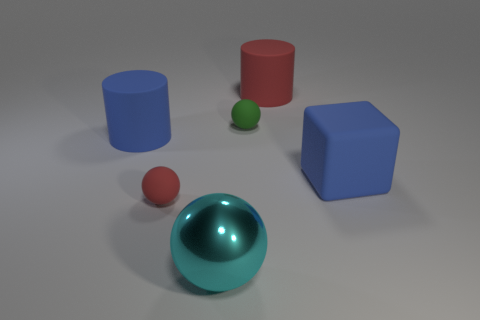Add 2 small things. How many objects exist? 8 Subtract all blocks. How many objects are left? 5 Add 4 cylinders. How many cylinders exist? 6 Subtract 0 gray cylinders. How many objects are left? 6 Subtract all large matte cubes. Subtract all blue things. How many objects are left? 3 Add 2 big blocks. How many big blocks are left? 3 